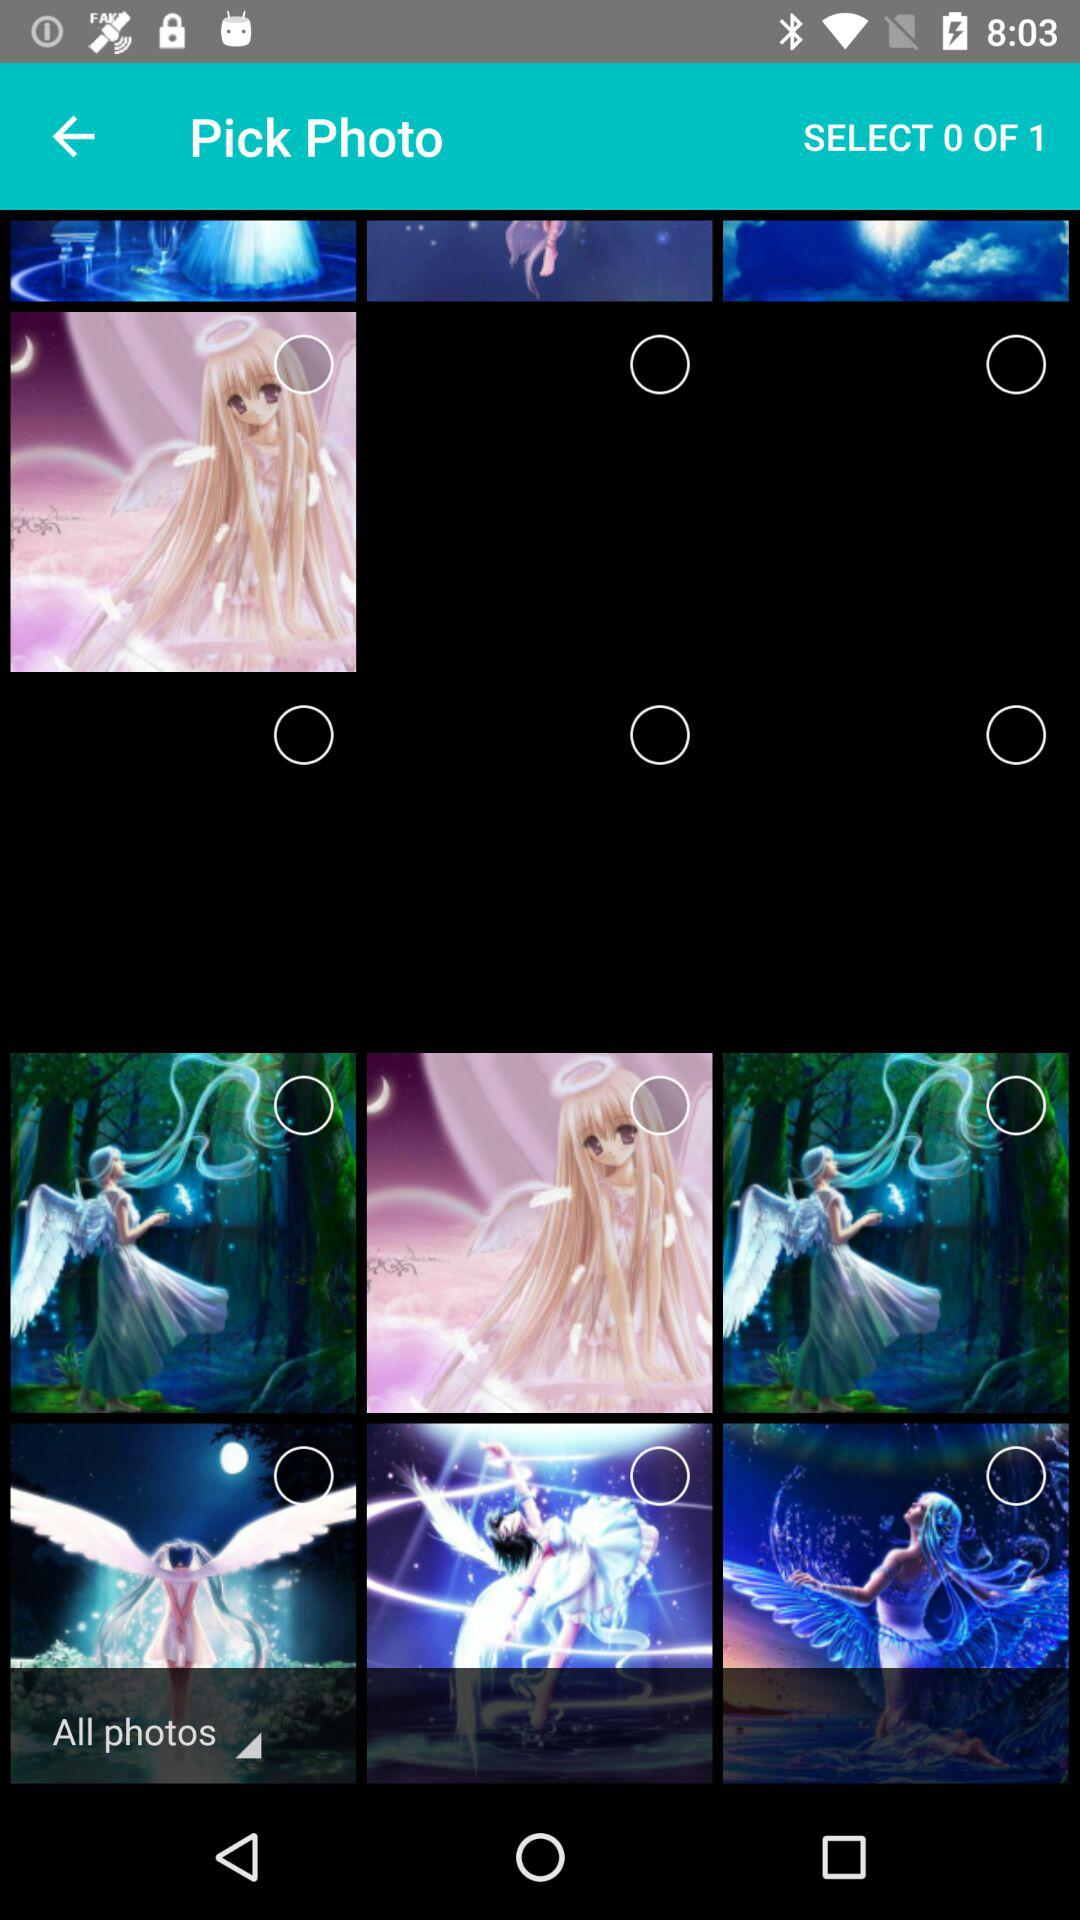What are the total number of photos present on the screen?
When the provided information is insufficient, respond with <no answer>. <no answer> 